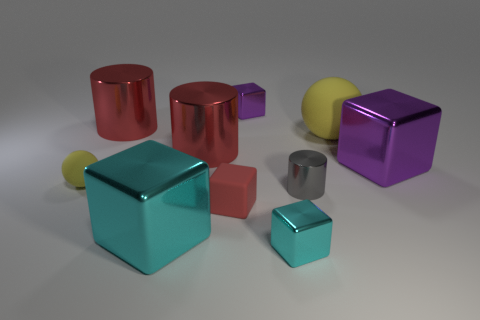Subtract all red cubes. How many cubes are left? 4 Subtract all big purple blocks. How many blocks are left? 4 Subtract all blue cubes. Subtract all brown spheres. How many cubes are left? 5 Subtract all balls. How many objects are left? 8 Add 5 large cyan blocks. How many large cyan blocks exist? 6 Subtract 0 gray spheres. How many objects are left? 10 Subtract all small yellow shiny spheres. Subtract all gray metal cylinders. How many objects are left? 9 Add 7 tiny spheres. How many tiny spheres are left? 8 